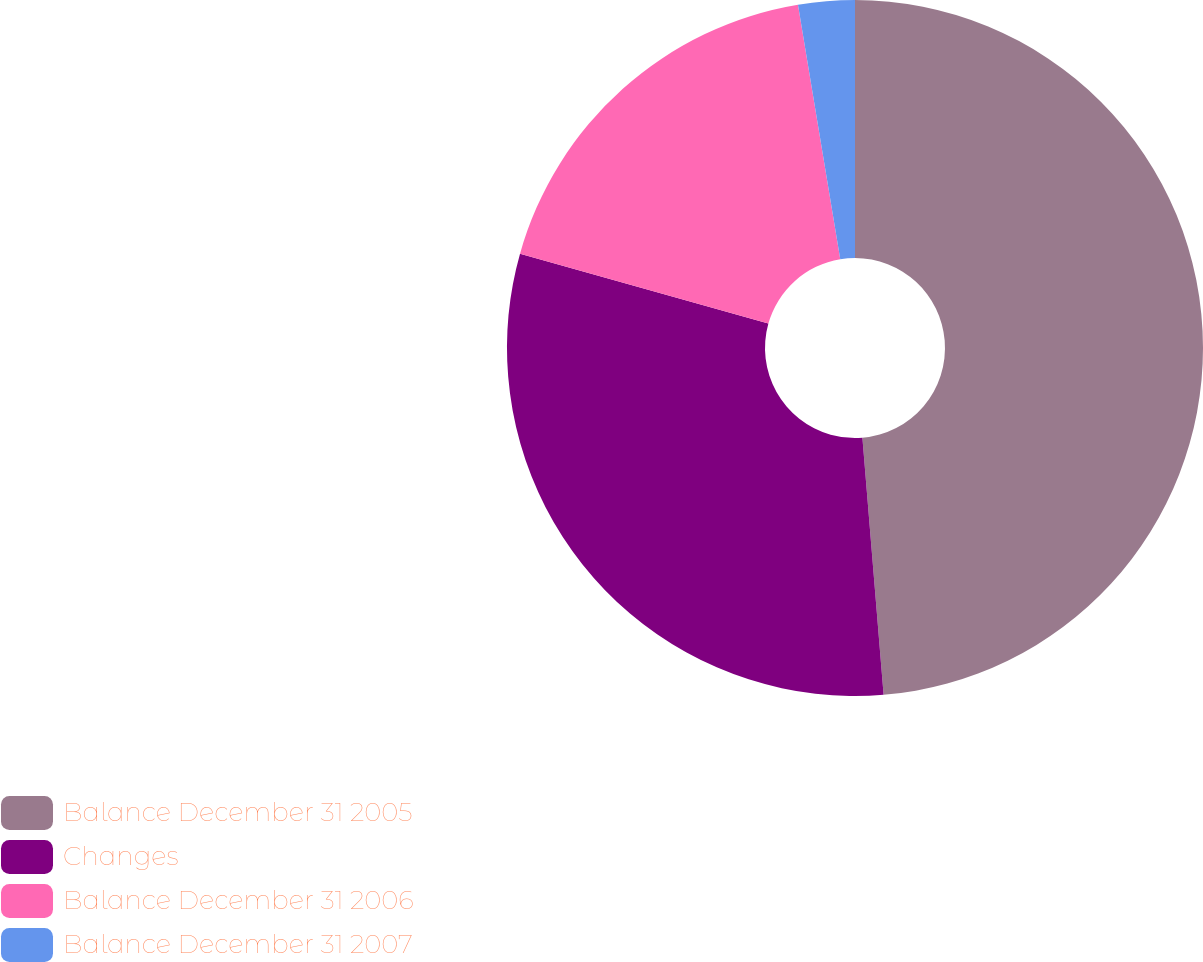Convert chart to OTSL. <chart><loc_0><loc_0><loc_500><loc_500><pie_chart><fcel>Balance December 31 2005<fcel>Changes<fcel>Balance December 31 2006<fcel>Balance December 31 2007<nl><fcel>48.69%<fcel>30.68%<fcel>18.01%<fcel>2.62%<nl></chart> 